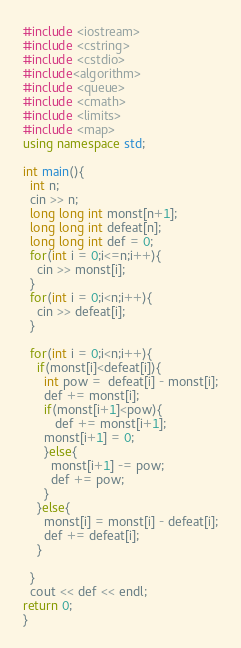<code> <loc_0><loc_0><loc_500><loc_500><_C++_>#include <iostream>
#include <cstring>
#include <cstdio>
#include<algorithm>
#include <queue>
#include <cmath>
#include <limits>
#include <map>
using namespace std;

int main(){
  int n;
  cin >> n;
  long long int monst[n+1];
  long long int defeat[n];
  long long int def = 0;
  for(int i = 0;i<=n;i++){
    cin >> monst[i];
  }
  for(int i = 0;i<n;i++){
    cin >> defeat[i];
  }
  
  for(int i = 0;i<n;i++){
    if(monst[i]<defeat[i]){
      int pow =  defeat[i] - monst[i];
      def += monst[i];
      if(monst[i+1]<pow){
         def += monst[i+1];
      monst[i+1] = 0;
      }else{
        monst[i+1] -= pow;
        def += pow;
      }
    }else{
      monst[i] = monst[i] - defeat[i];
      def += defeat[i];
    }
    
  }
  cout << def << endl;
return 0;
}</code> 